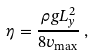<formula> <loc_0><loc_0><loc_500><loc_500>\eta = \frac { \rho g L _ { y } ^ { 2 } } { 8 v _ { \max } } \, ,</formula> 